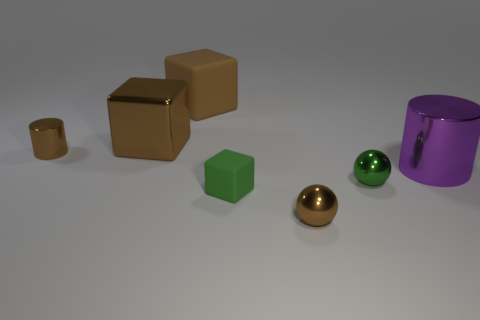Subtract all gray blocks. Subtract all gray cylinders. How many blocks are left? 3 Add 2 cyan cylinders. How many objects exist? 9 Subtract all cubes. How many objects are left? 4 Subtract 1 brown spheres. How many objects are left? 6 Subtract all shiny cylinders. Subtract all rubber spheres. How many objects are left? 5 Add 4 tiny brown spheres. How many tiny brown spheres are left? 5 Add 1 brown things. How many brown things exist? 5 